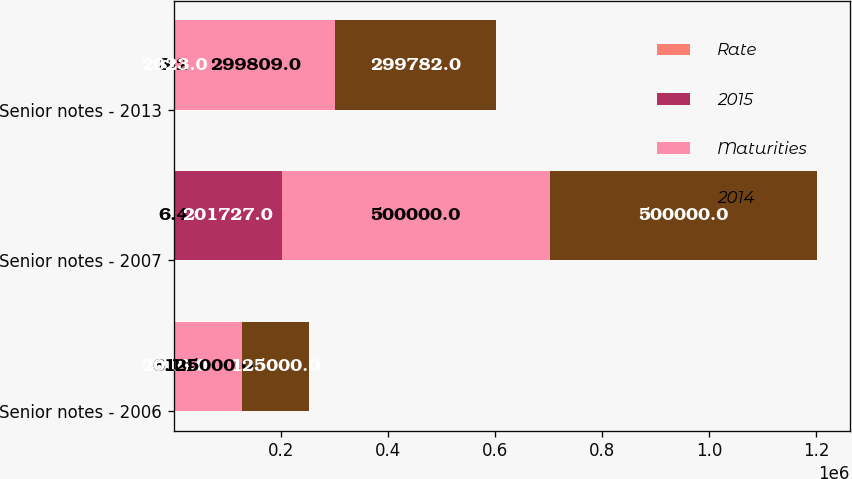Convert chart. <chart><loc_0><loc_0><loc_500><loc_500><stacked_bar_chart><ecel><fcel>Senior notes - 2006<fcel>Senior notes - 2007<fcel>Senior notes - 2013<nl><fcel>Rate<fcel>6.14<fcel>6.4<fcel>3.2<nl><fcel>2015<fcel>2016<fcel>201727<fcel>2023<nl><fcel>Maturities<fcel>125000<fcel>500000<fcel>299809<nl><fcel>2014<fcel>125000<fcel>500000<fcel>299782<nl></chart> 